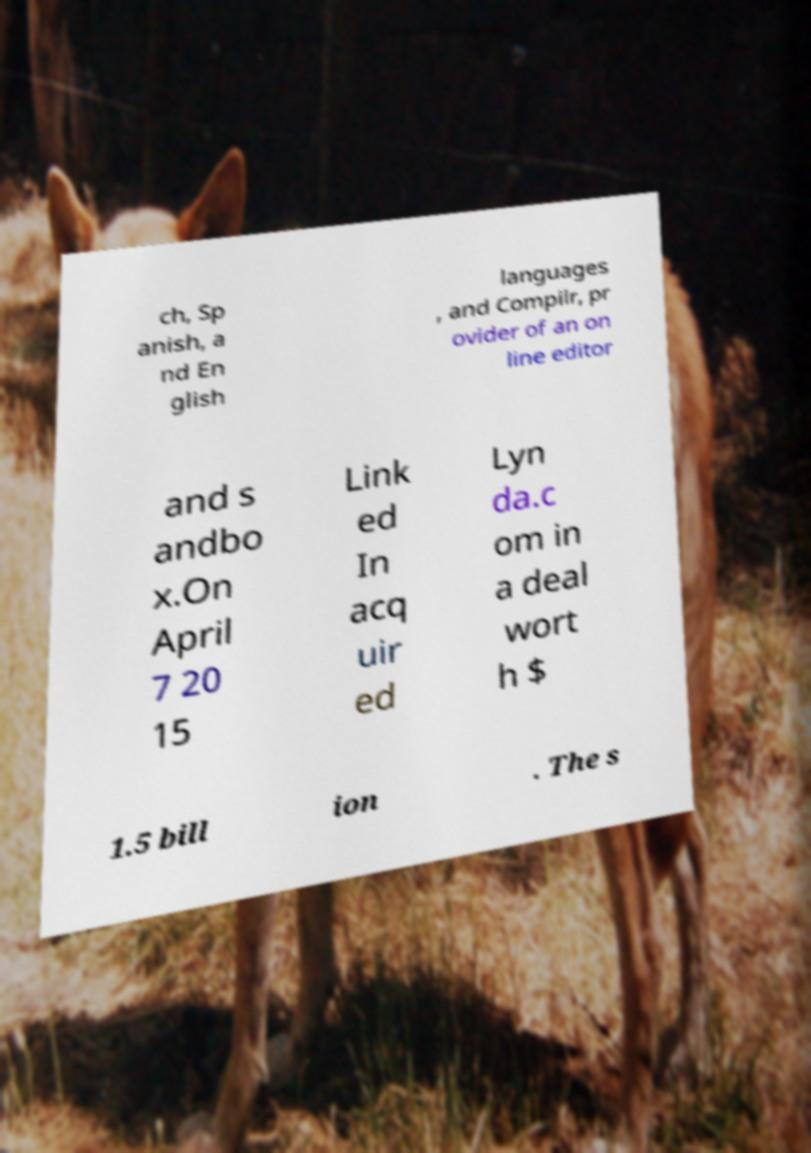Please read and relay the text visible in this image. What does it say? ch, Sp anish, a nd En glish languages , and Compilr, pr ovider of an on line editor and s andbo x.On April 7 20 15 Link ed In acq uir ed Lyn da.c om in a deal wort h $ 1.5 bill ion . The s 